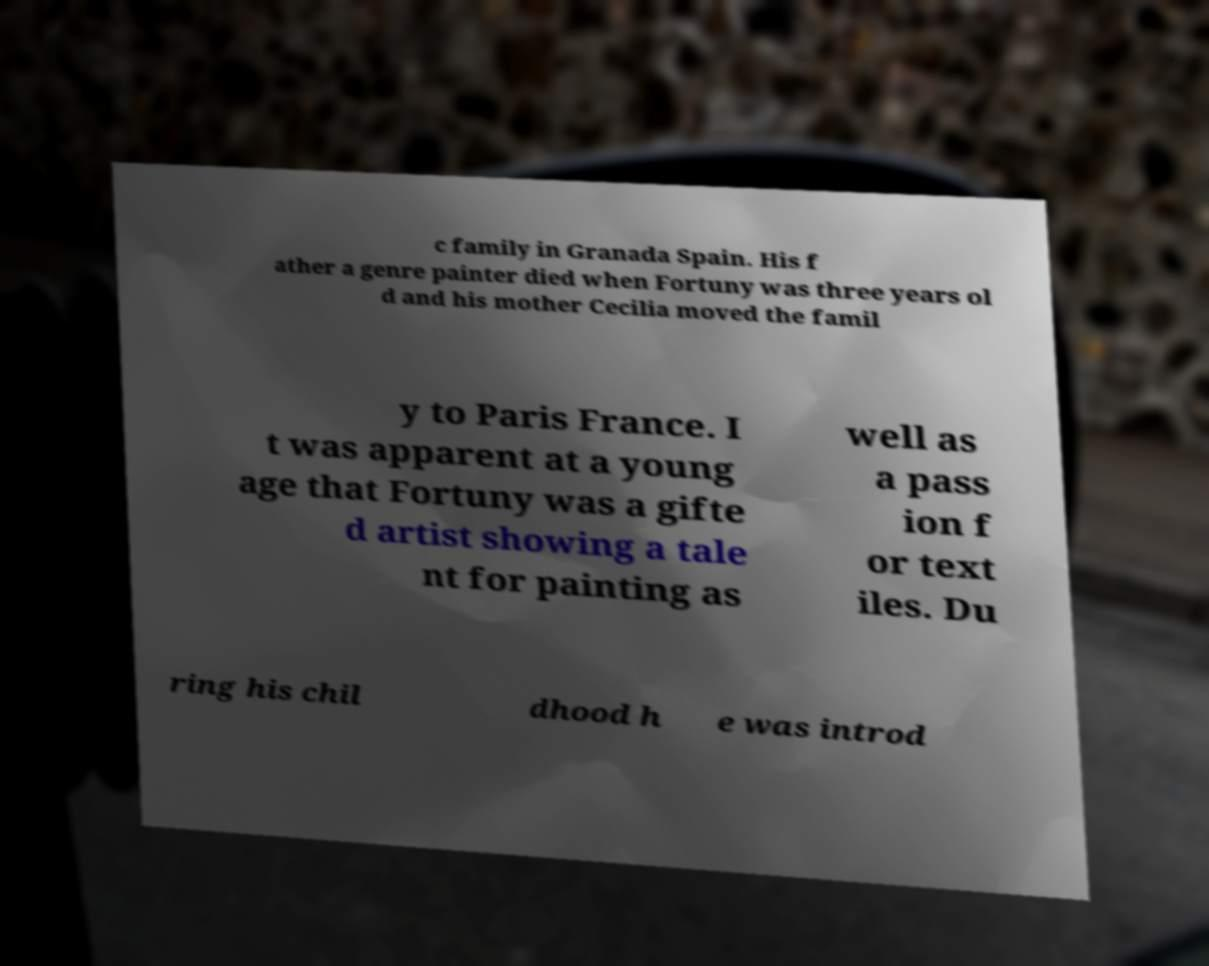Please identify and transcribe the text found in this image. c family in Granada Spain. His f ather a genre painter died when Fortuny was three years ol d and his mother Cecilia moved the famil y to Paris France. I t was apparent at a young age that Fortuny was a gifte d artist showing a tale nt for painting as well as a pass ion f or text iles. Du ring his chil dhood h e was introd 